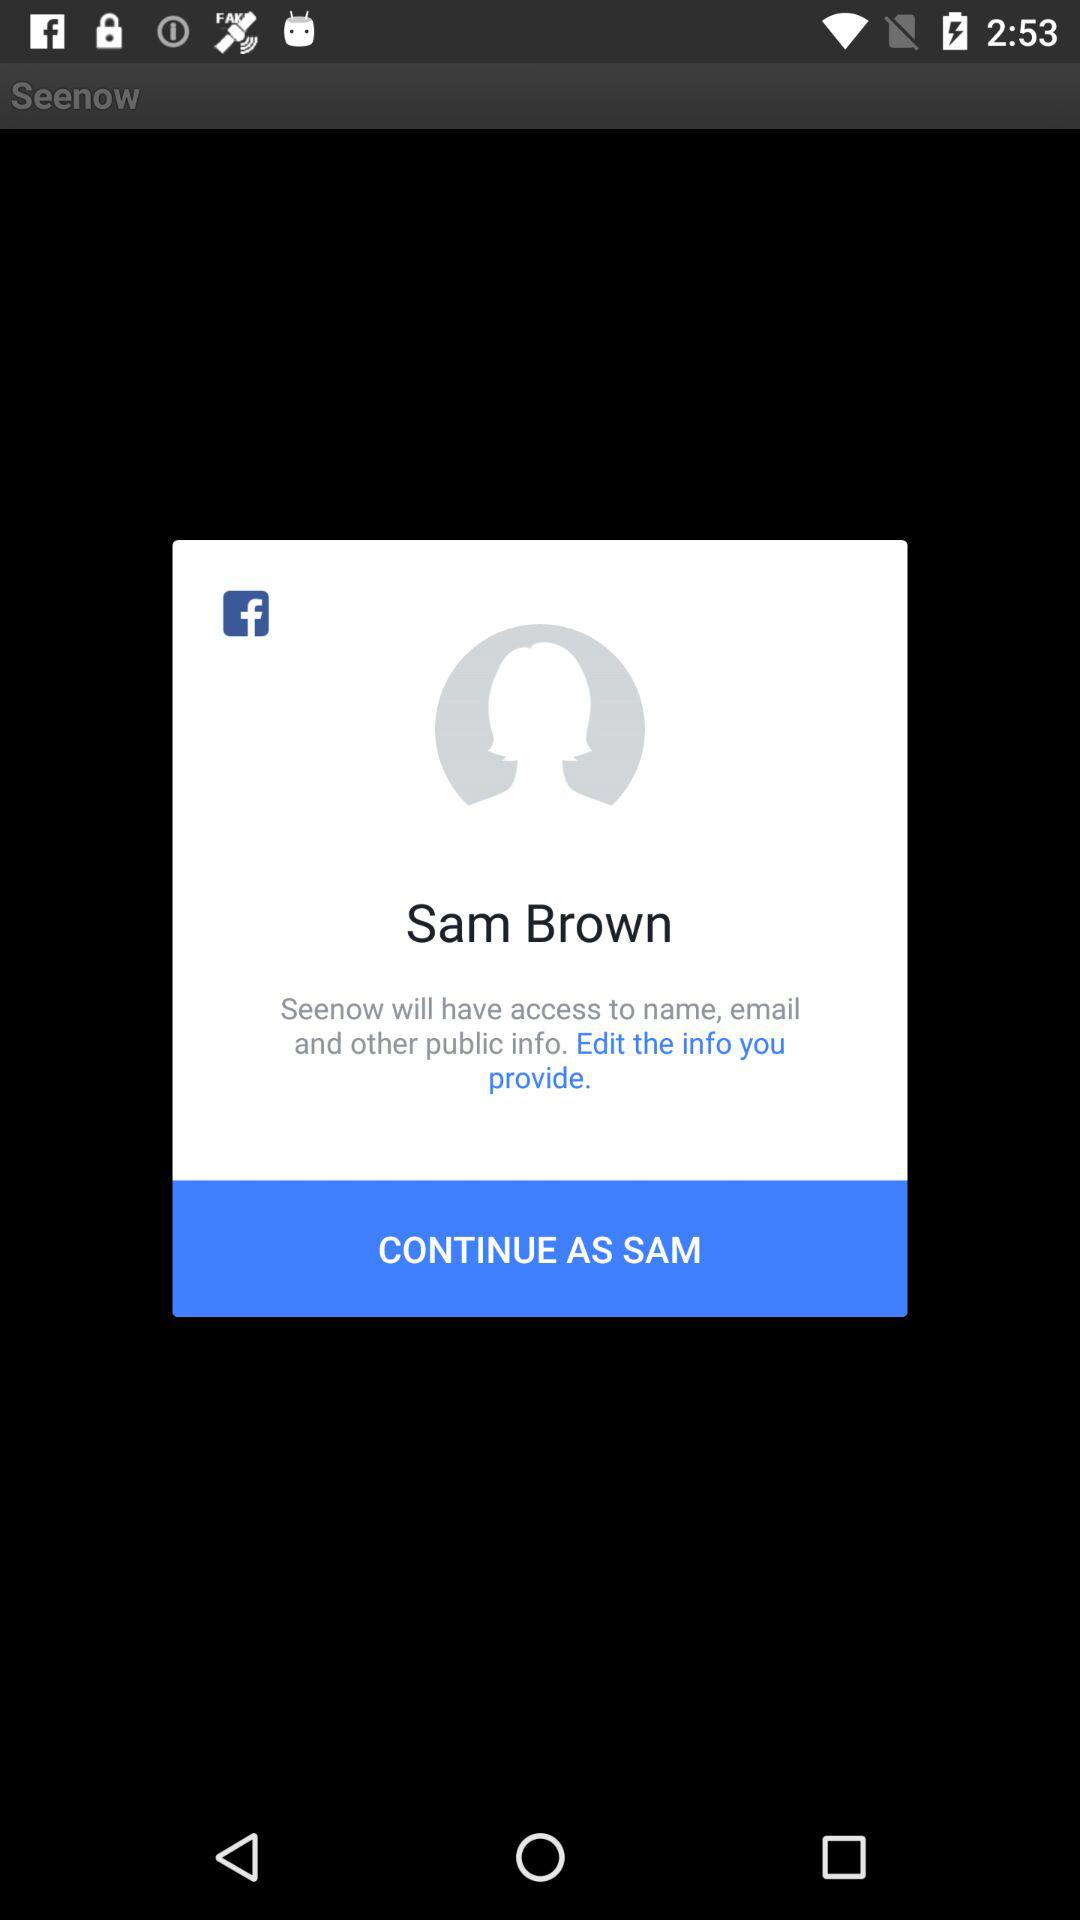What is the user name? The user name is Sam Brown. 